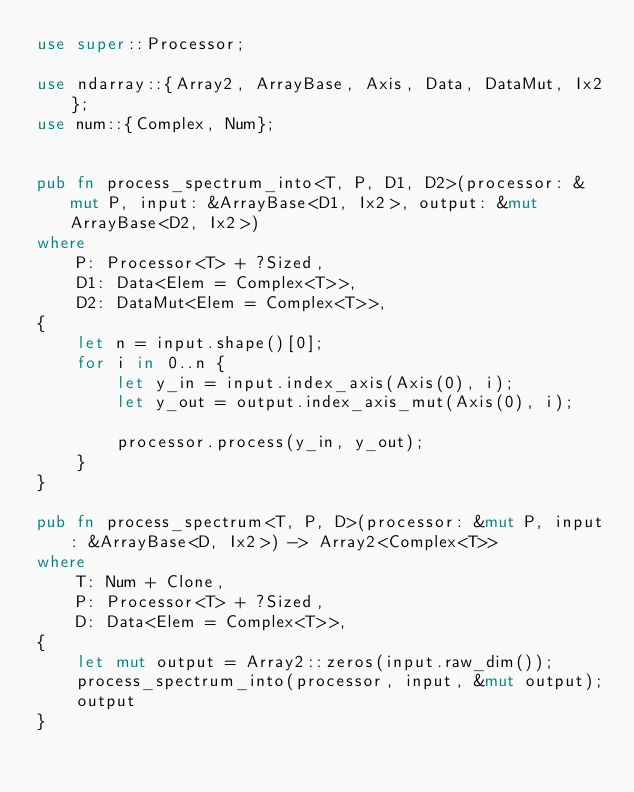Convert code to text. <code><loc_0><loc_0><loc_500><loc_500><_Rust_>use super::Processor;

use ndarray::{Array2, ArrayBase, Axis, Data, DataMut, Ix2};
use num::{Complex, Num};


pub fn process_spectrum_into<T, P, D1, D2>(processor: &mut P, input: &ArrayBase<D1, Ix2>, output: &mut ArrayBase<D2, Ix2>)
where
    P: Processor<T> + ?Sized,
    D1: Data<Elem = Complex<T>>,
    D2: DataMut<Elem = Complex<T>>,
{
    let n = input.shape()[0];
    for i in 0..n {
        let y_in = input.index_axis(Axis(0), i);
        let y_out = output.index_axis_mut(Axis(0), i);

        processor.process(y_in, y_out);
    }
}

pub fn process_spectrum<T, P, D>(processor: &mut P, input: &ArrayBase<D, Ix2>) -> Array2<Complex<T>>
where
    T: Num + Clone,
    P: Processor<T> + ?Sized,
    D: Data<Elem = Complex<T>>,
{
    let mut output = Array2::zeros(input.raw_dim());
    process_spectrum_into(processor, input, &mut output);
    output
}
</code> 